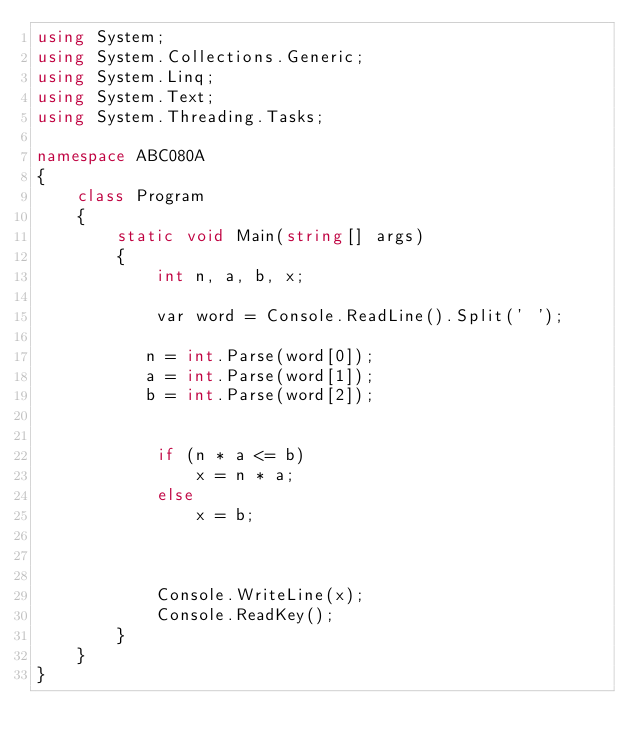Convert code to text. <code><loc_0><loc_0><loc_500><loc_500><_C#_>using System;
using System.Collections.Generic;
using System.Linq;
using System.Text;
using System.Threading.Tasks;

namespace ABC080A
{
    class Program
    {
        static void Main(string[] args)
        {
            int n, a, b, x;

            var word = Console.ReadLine().Split(' ');

           n = int.Parse(word[0]);
           a = int.Parse(word[1]);
           b = int.Parse(word[2]);


			if (n * a <= b)
				x = n * a;
			else
				x = b;
           
             

            Console.WriteLine(x);
            Console.ReadKey();
        }
    }
}
</code> 